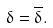<formula> <loc_0><loc_0><loc_500><loc_500>\delta = \overline { \delta } .</formula> 